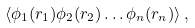Convert formula to latex. <formula><loc_0><loc_0><loc_500><loc_500>\langle \phi _ { 1 } ( r _ { 1 } ) \phi _ { 2 } ( r _ { 2 } ) \dots \phi _ { n } ( r _ { n } ) \rangle \, ,</formula> 